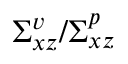<formula> <loc_0><loc_0><loc_500><loc_500>\Sigma _ { x z } ^ { v } / \Sigma _ { x z } ^ { p }</formula> 